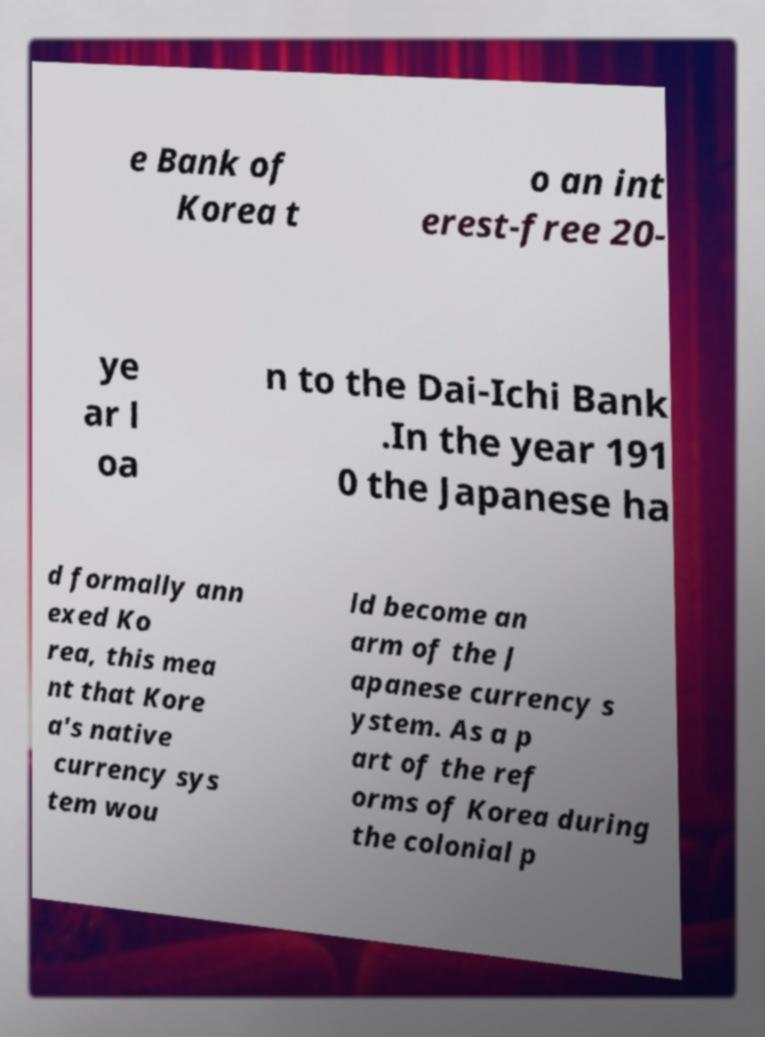Please read and relay the text visible in this image. What does it say? e Bank of Korea t o an int erest-free 20- ye ar l oa n to the Dai-Ichi Bank .In the year 191 0 the Japanese ha d formally ann exed Ko rea, this mea nt that Kore a's native currency sys tem wou ld become an arm of the J apanese currency s ystem. As a p art of the ref orms of Korea during the colonial p 